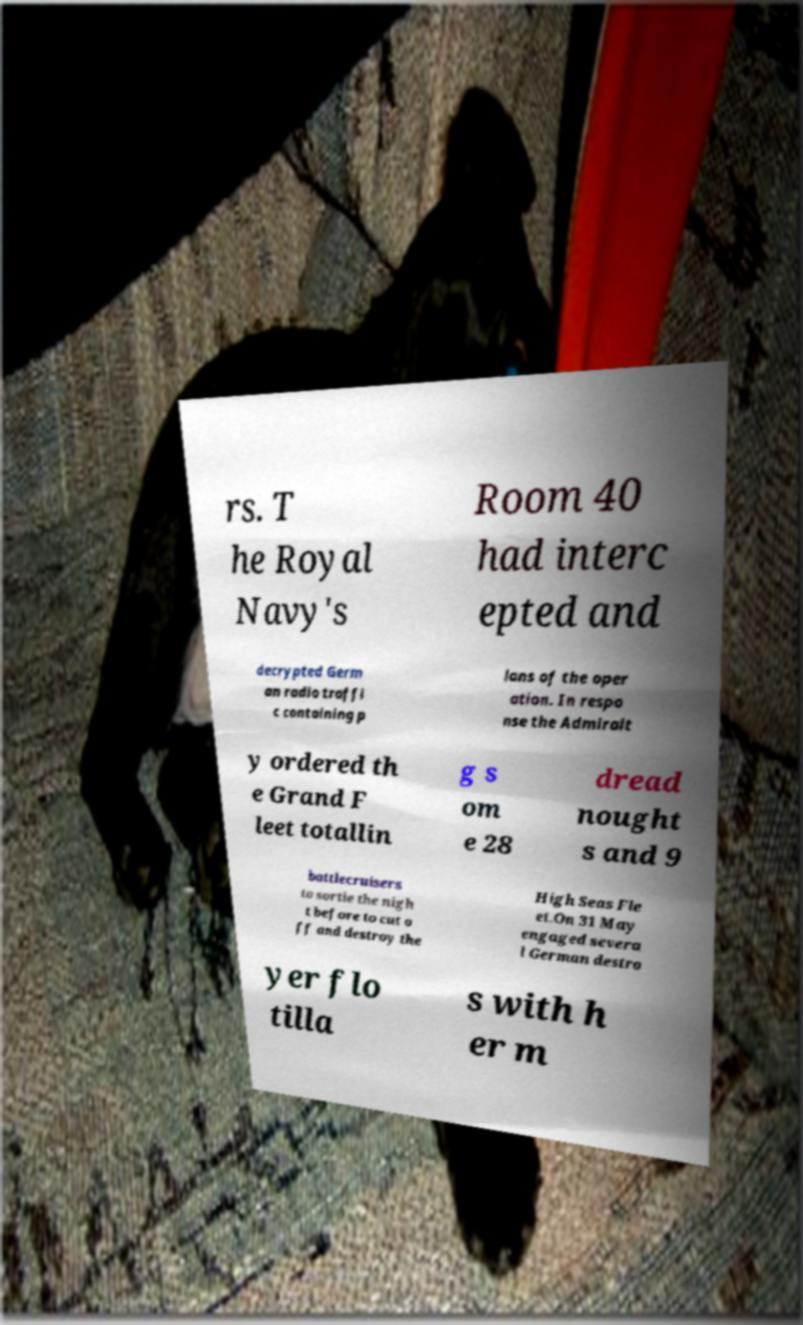Can you read and provide the text displayed in the image?This photo seems to have some interesting text. Can you extract and type it out for me? rs. T he Royal Navy's Room 40 had interc epted and decrypted Germ an radio traffi c containing p lans of the oper ation. In respo nse the Admiralt y ordered th e Grand F leet totallin g s om e 28 dread nought s and 9 battlecruisers to sortie the nigh t before to cut o ff and destroy the High Seas Fle et.On 31 May engaged severa l German destro yer flo tilla s with h er m 